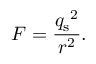<formula> <loc_0><loc_0><loc_500><loc_500>F = { \frac { { q _ { s } } ^ { 2 } } { r ^ { 2 } } } .</formula> 